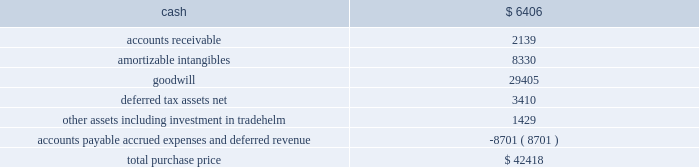Table of contents marketaxess holdings inc .
Notes to consolidated financial statements 2014 ( continued ) of this standard had no material effect on the company 2019s consolidated statements of financial condition and consolidated statements of operations .
Reclassifications certain reclassifications have been made to the prior years 2019 financial statements in order to conform to the current year presentation .
Such reclassifications had no effect on previously reported net income .
On march 5 , 2008 , the company acquired all of the outstanding capital stock of greenline financial technologies , inc .
( 201cgreenline 201d ) , an illinois-based provider of integration , testing and management solutions for fix-related products and services designed to optimize electronic trading of fixed-income , equity and other exchange-based products , and approximately ten percent of the outstanding capital stock of tradehelm , inc. , a delaware corporation that was spun-out from greenline immediately prior to the acquisition .
The acquisition of greenline broadens the range of technology services that the company offers to institutional financial markets , provides an expansion of the company 2019s client base , including global exchanges and hedge funds , and further diversifies the company 2019s revenues beyond the core electronic credit trading products .
The results of operations of greenline are included in the consolidated financial statements from the date of the acquisition .
The aggregate consideration for the greenline acquisition was $ 41.1 million , comprised of $ 34.7 million in cash , 725923 shares of common stock valued at $ 5.8 million and $ 0.6 million of acquisition-related costs .
In addition , the sellers were eligible to receive up to an aggregate of $ 3.0 million in cash , subject to greenline attaining certain earn- out targets in 2008 and 2009 .
A total of $ 1.4 million was paid to the sellers in 2009 based on the 2008 earn-out target , bringing the aggregate consideration to $ 42.4 million .
The 2009 earn-out target was not met .
A total of $ 2.0 million of the purchase price , which had been deposited into escrow accounts to satisfy potential indemnity claims , was distributed to the sellers in march 2009 .
The shares of common stock issued to each selling shareholder of greenline were released in two equal installments on december 20 , 2008 and december 20 , 2009 , respectively .
The value ascribed to the shares was discounted from the market value to reflect the non-marketability of such shares during the restriction period .
The purchase price allocation is as follows ( in thousands ) : the amortizable intangibles include $ 3.2 million of acquired technology , $ 3.3 million of customer relationships , $ 1.3 million of non-competition agreements and $ 0.5 million of tradenames .
Useful lives of ten years and five years have been assigned to the customer relationships intangible and all other amortizable intangibles , respectively .
The identifiable intangible assets and goodwill are not deductible for tax purposes .
The following unaudited pro forma consolidated financial information reflects the results of operations of the company for the years ended december 31 , 2008 and 2007 , as if the acquisition of greenline had occurred as of the beginning of the period presented , after giving effect to certain purchase accounting adjustments .
These pro forma results are not necessarily indicative of what the company 2019s operating results would have been had the acquisition actually taken place as of the beginning of the earliest period presented .
The pro forma financial information 3 .
Acquisitions .

What percentage of the aggregate consideration for the greenline acquisition was paid to the sellers in 2009 based on the 2008 earn-out target? 
Computations: (1.4 / 42.4)
Answer: 0.03302. 